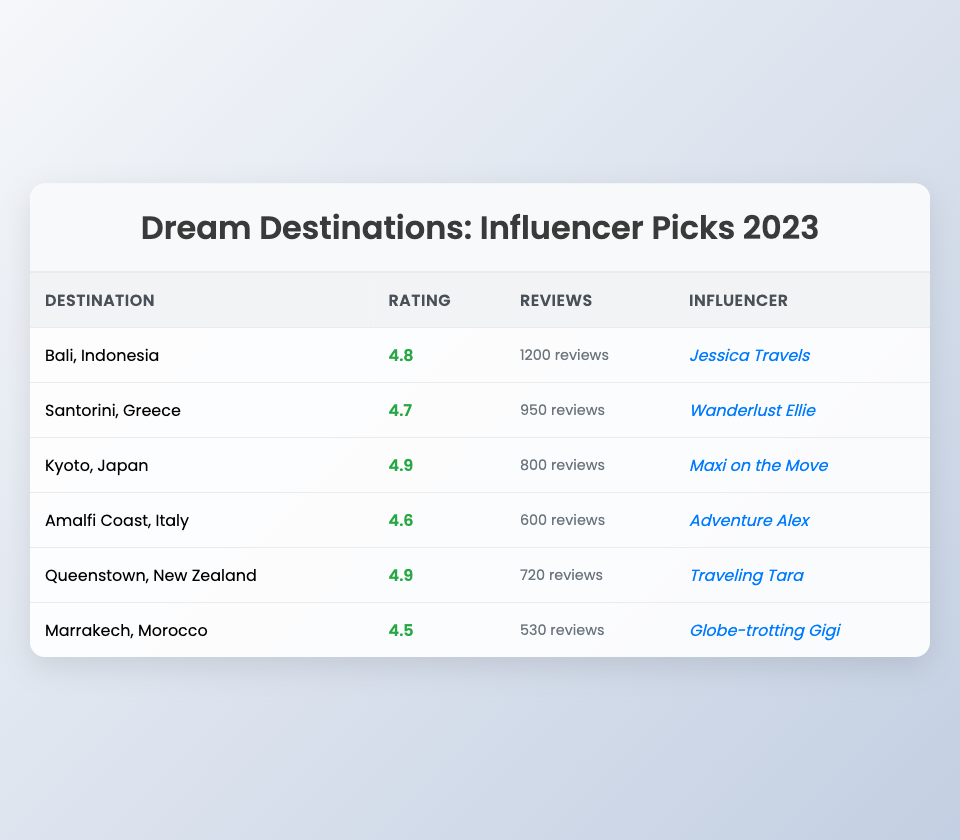What is the average rating of all listed travel destinations? To find the average rating, sum all the average ratings (4.8 + 4.7 + 4.9 + 4.6 + 4.9 + 4.5 = 28.4). Then, divide this total by the number of destinations, which is 6. Therefore, the average rating is 28.4 / 6 = 4.73.
Answer: 4.73 Which influencer featured Kyoto, Japan? From the table, the influencer who featured Kyoto, Japan is Maxi on the Move.
Answer: Maxi on the Move What is the highest average rating among the destinations? By comparing the average ratings, Bali, Indonesia (4.8) and Queenstown, New Zealand (4.9) are checked. The highest is Queenstown, New Zealand with 4.9.
Answer: 4.9 Is Marrakech, Morocco rated higher than Amalfi Coast, Italy? Checking the ratings, Marrakech has an average rating of 4.5 while the Amalfi Coast has 4.6. Since 4.5 is less than 4.6, Marrakech is not rated higher.
Answer: No How many reviews did Santorini, Greece receive? Looking at the table, Santorini, Greece has 950 reviews listed next to it.
Answer: 950 reviews What is the total number of reviews for the top three rated destinations? The top three rated destinations are Kyoto (4.9, 800 reviews), Queenstown (4.9, 720 reviews), and Bali (4.8, 1200 reviews). Adding these together gives a total of 800 + 720 + 1200 = 2720 reviews.
Answer: 2720 reviews Which travel destination had the least number of reviews and what is its average rating? By examining the reviews, Marrakech, Morocco has the least at 530 reviews. Its average rating is 4.5.
Answer: Marrakech, Morocco with 4.5 Did any of the influencers feature more than one destination? Reviewing the table, no influencer is listed more than once. Each influencer features a unique destination.
Answer: No What is the difference in average ratings between the highest and lowest rated destinations? The highest rated destination is Queenstown, New Zealand with an average rating of 4.9 and the lowest is Marrakech, Morocco with 4.5. The difference is 4.9 - 4.5 = 0.4.
Answer: 0.4 